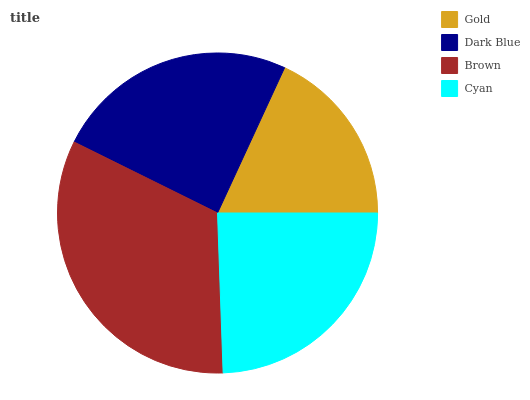Is Gold the minimum?
Answer yes or no. Yes. Is Brown the maximum?
Answer yes or no. Yes. Is Dark Blue the minimum?
Answer yes or no. No. Is Dark Blue the maximum?
Answer yes or no. No. Is Dark Blue greater than Gold?
Answer yes or no. Yes. Is Gold less than Dark Blue?
Answer yes or no. Yes. Is Gold greater than Dark Blue?
Answer yes or no. No. Is Dark Blue less than Gold?
Answer yes or no. No. Is Dark Blue the high median?
Answer yes or no. Yes. Is Cyan the low median?
Answer yes or no. Yes. Is Gold the high median?
Answer yes or no. No. Is Dark Blue the low median?
Answer yes or no. No. 